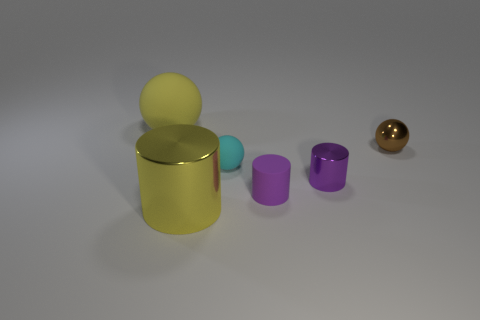Are there any purple things made of the same material as the small brown thing?
Provide a short and direct response. Yes. Is the number of matte objects that are to the left of the yellow rubber object less than the number of big red spheres?
Your response must be concise. No. What is the material of the big yellow thing that is right of the yellow object that is left of the yellow metal cylinder?
Ensure brevity in your answer.  Metal. The object that is to the left of the small cyan rubber object and behind the big cylinder has what shape?
Provide a succinct answer. Sphere. What number of other things are there of the same color as the shiny ball?
Offer a very short reply. 0. What number of things are either objects that are on the right side of the big yellow matte ball or brown cylinders?
Provide a short and direct response. 5. There is a big metal object; is it the same color as the large object that is behind the small cyan object?
Your answer should be very brief. Yes. There is a rubber sphere that is on the right side of the yellow thing that is behind the big cylinder; what is its size?
Provide a short and direct response. Small. What number of objects are tiny purple shiny things or large yellow objects behind the purple rubber cylinder?
Offer a terse response. 2. Do the small rubber object that is behind the small shiny cylinder and the brown metal thing have the same shape?
Give a very brief answer. Yes. 